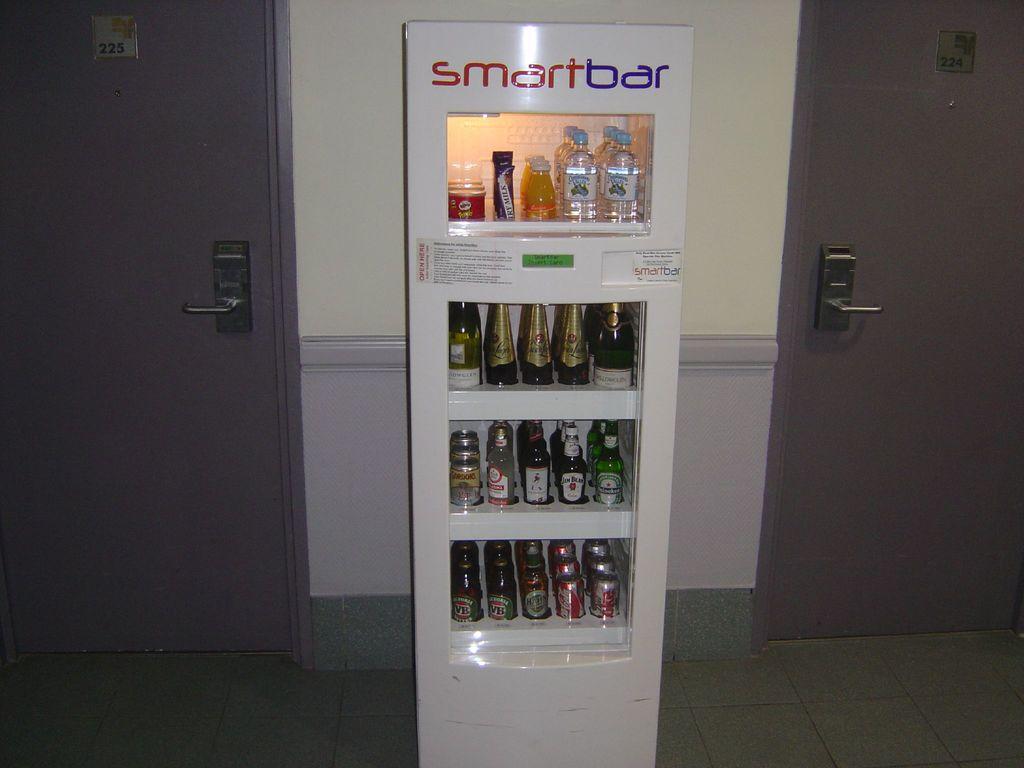/what is the name of this bar?
Offer a very short reply. Smartbar. What is written on the clear bottles?
Your response must be concise. Unanswerable. 